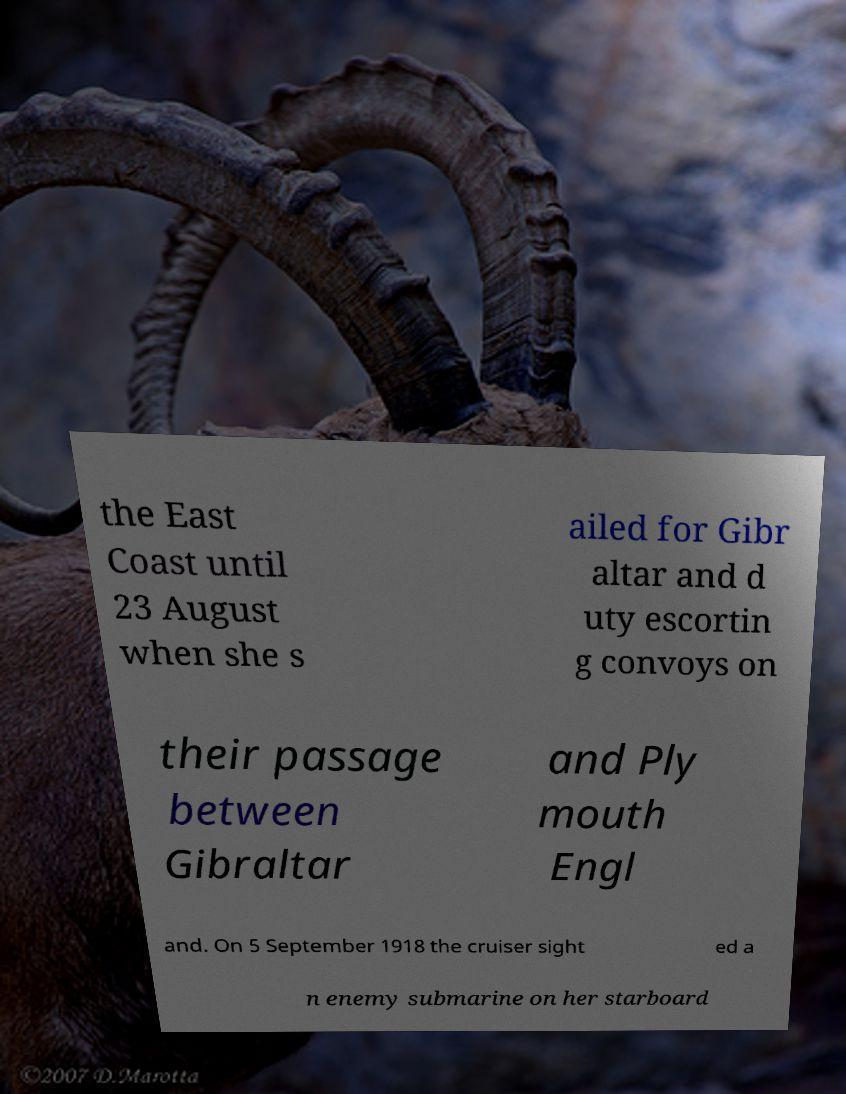Could you assist in decoding the text presented in this image and type it out clearly? the East Coast until 23 August when she s ailed for Gibr altar and d uty escortin g convoys on their passage between Gibraltar and Ply mouth Engl and. On 5 September 1918 the cruiser sight ed a n enemy submarine on her starboard 